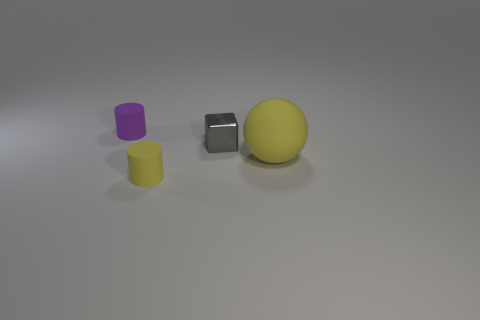Is there a tiny object that has the same material as the yellow cylinder?
Your answer should be very brief. Yes. What is the size of the matte object that is the same color as the rubber ball?
Give a very brief answer. Small. There is a small thing to the right of the small cylinder that is to the right of the purple thing; what is its material?
Provide a succinct answer. Metal. How many matte cylinders have the same color as the block?
Your response must be concise. 0. There is a yellow cylinder that is the same material as the purple cylinder; what size is it?
Keep it short and to the point. Small. There is a small rubber object behind the tiny gray shiny thing; what is its shape?
Your answer should be compact. Cylinder. What is the size of the purple rubber object that is the same shape as the small yellow matte thing?
Your answer should be very brief. Small. There is a rubber cylinder that is in front of the cylinder behind the big yellow object; what number of objects are behind it?
Your response must be concise. 3. Are there an equal number of tiny purple objects that are in front of the yellow rubber cylinder and big purple shiny objects?
Provide a succinct answer. Yes. What number of balls are either large rubber things or tiny gray metallic things?
Make the answer very short. 1. 